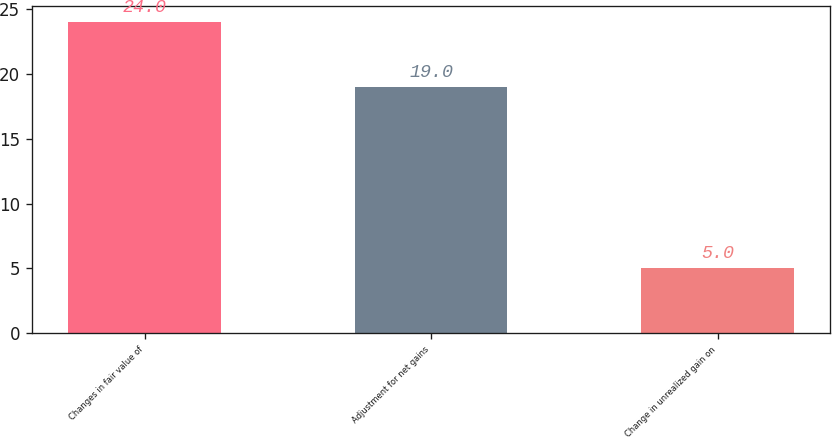<chart> <loc_0><loc_0><loc_500><loc_500><bar_chart><fcel>Changes in fair value of<fcel>Adjustment for net gains<fcel>Change in unrealized gain on<nl><fcel>24<fcel>19<fcel>5<nl></chart> 